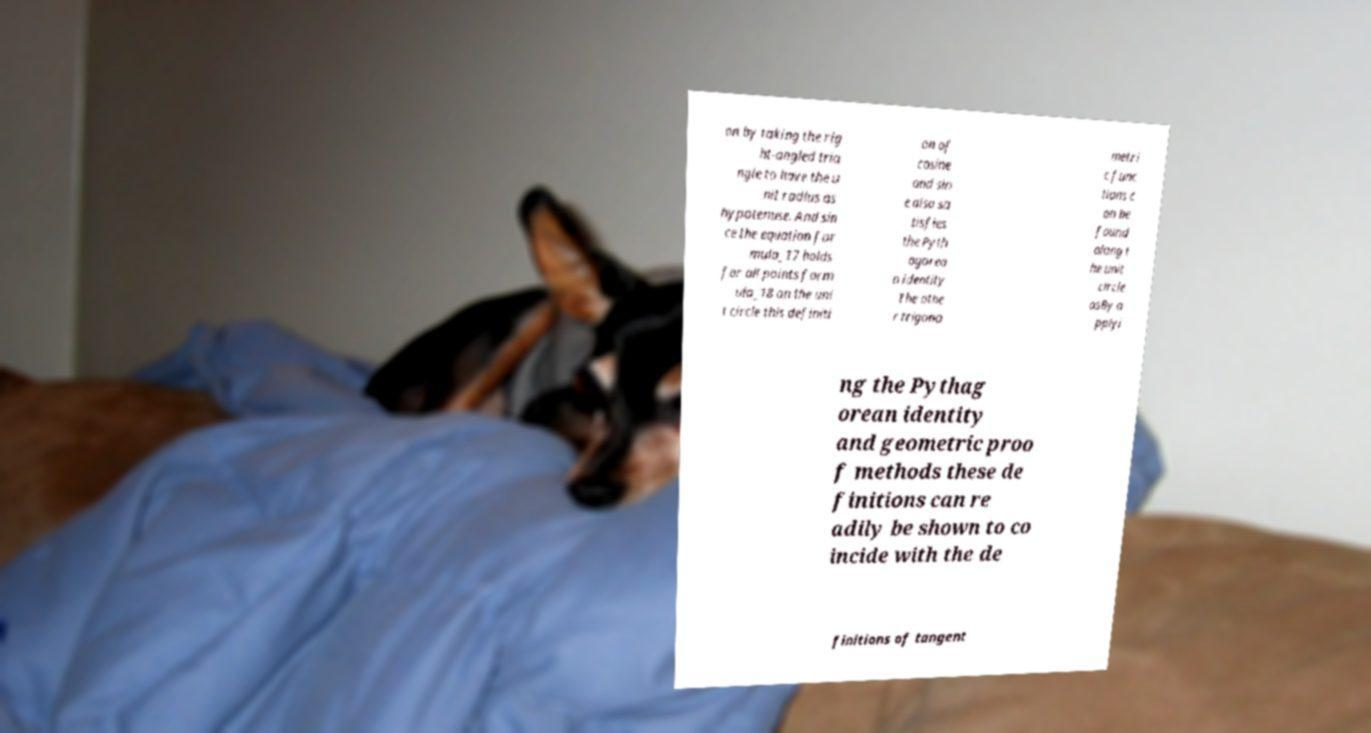For documentation purposes, I need the text within this image transcribed. Could you provide that? on by taking the rig ht-angled tria ngle to have the u nit radius as hypotenuse. And sin ce the equation for mula_17 holds for all points form ula_18 on the uni t circle this definiti on of cosine and sin e also sa tisfies the Pyth agorea n identity The othe r trigono metri c func tions c an be found along t he unit circle asBy a pplyi ng the Pythag orean identity and geometric proo f methods these de finitions can re adily be shown to co incide with the de finitions of tangent 